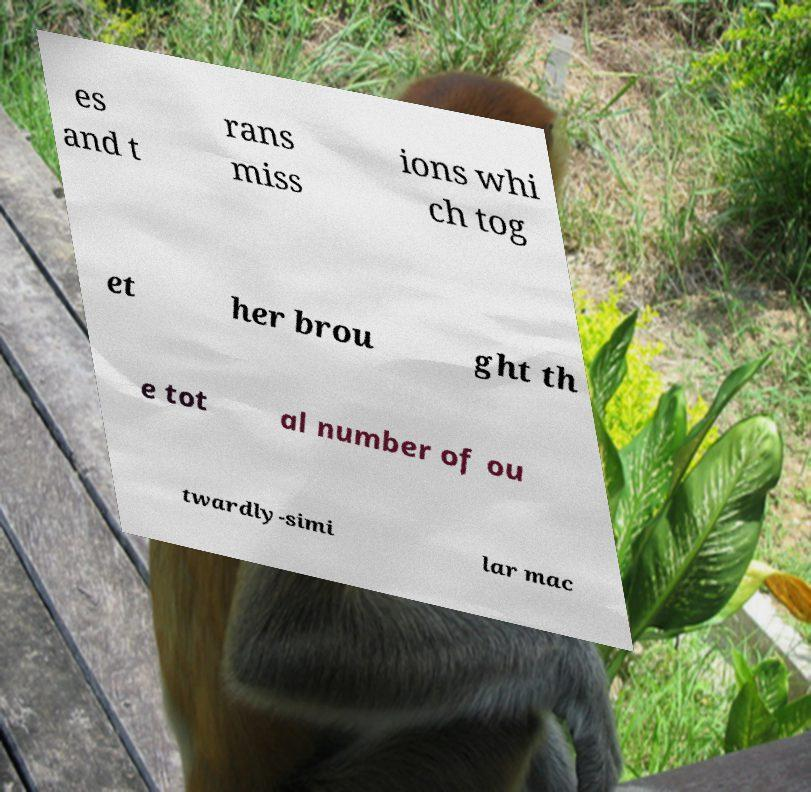I need the written content from this picture converted into text. Can you do that? es and t rans miss ions whi ch tog et her brou ght th e tot al number of ou twardly-simi lar mac 